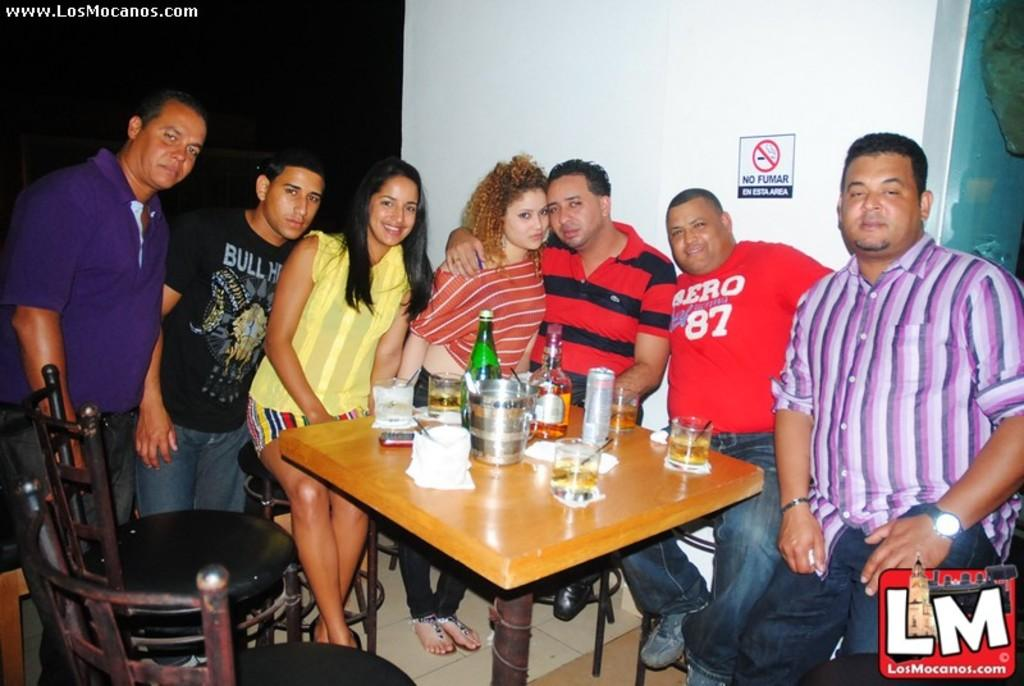What is the person in the image doing? The person is sitting on a chair in the image. What objects are on the table in the image? There are glasses, a bottle, and a paper on the table in the image. What can be seen in the background of the image? There is a board and a wall in the background of the image. What type of impulse can be seen affecting the person in the image? There is no impulse affecting the person in the image; they are simply sitting on a chair. Is there a ball visible in the image? No, there is no ball present in the image. 